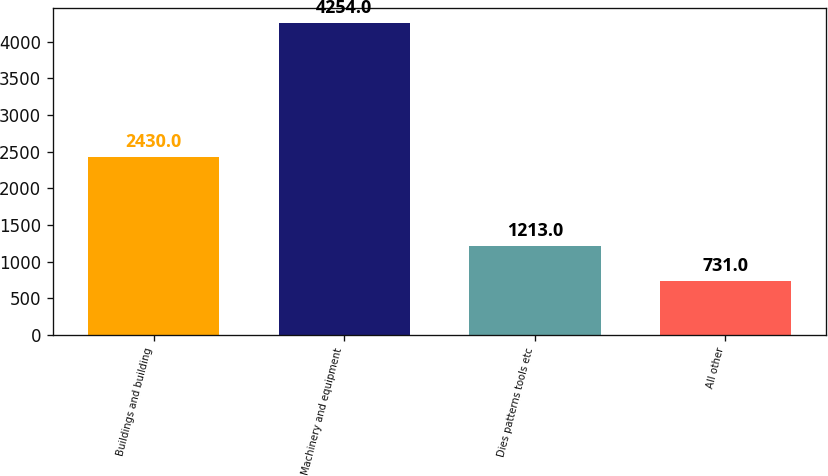Convert chart to OTSL. <chart><loc_0><loc_0><loc_500><loc_500><bar_chart><fcel>Buildings and building<fcel>Machinery and equipment<fcel>Dies patterns tools etc<fcel>All other<nl><fcel>2430<fcel>4254<fcel>1213<fcel>731<nl></chart> 